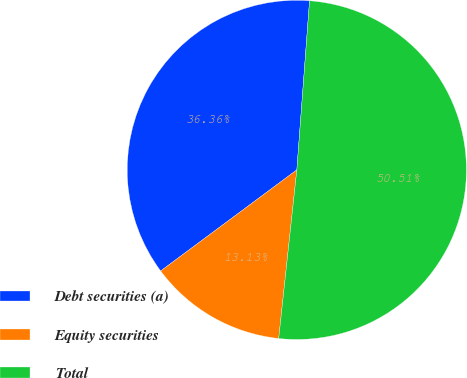Convert chart to OTSL. <chart><loc_0><loc_0><loc_500><loc_500><pie_chart><fcel>Debt securities (a)<fcel>Equity securities<fcel>Total<nl><fcel>36.36%<fcel>13.13%<fcel>50.51%<nl></chart> 